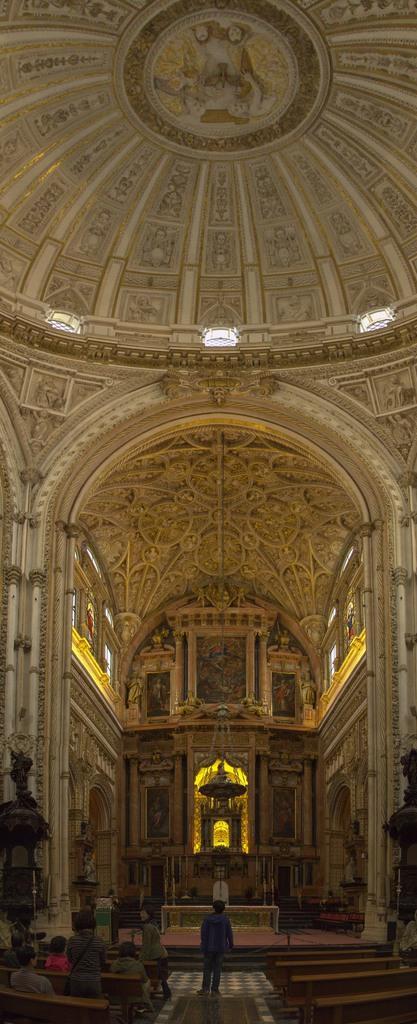Can you describe this image briefly? This is the inside picture of the church. In this image there are people sitting on the benches. In the center of the image there is a person standing on the mat. There is a statue. There are carvings on the wall. On top of the image there are lights. 